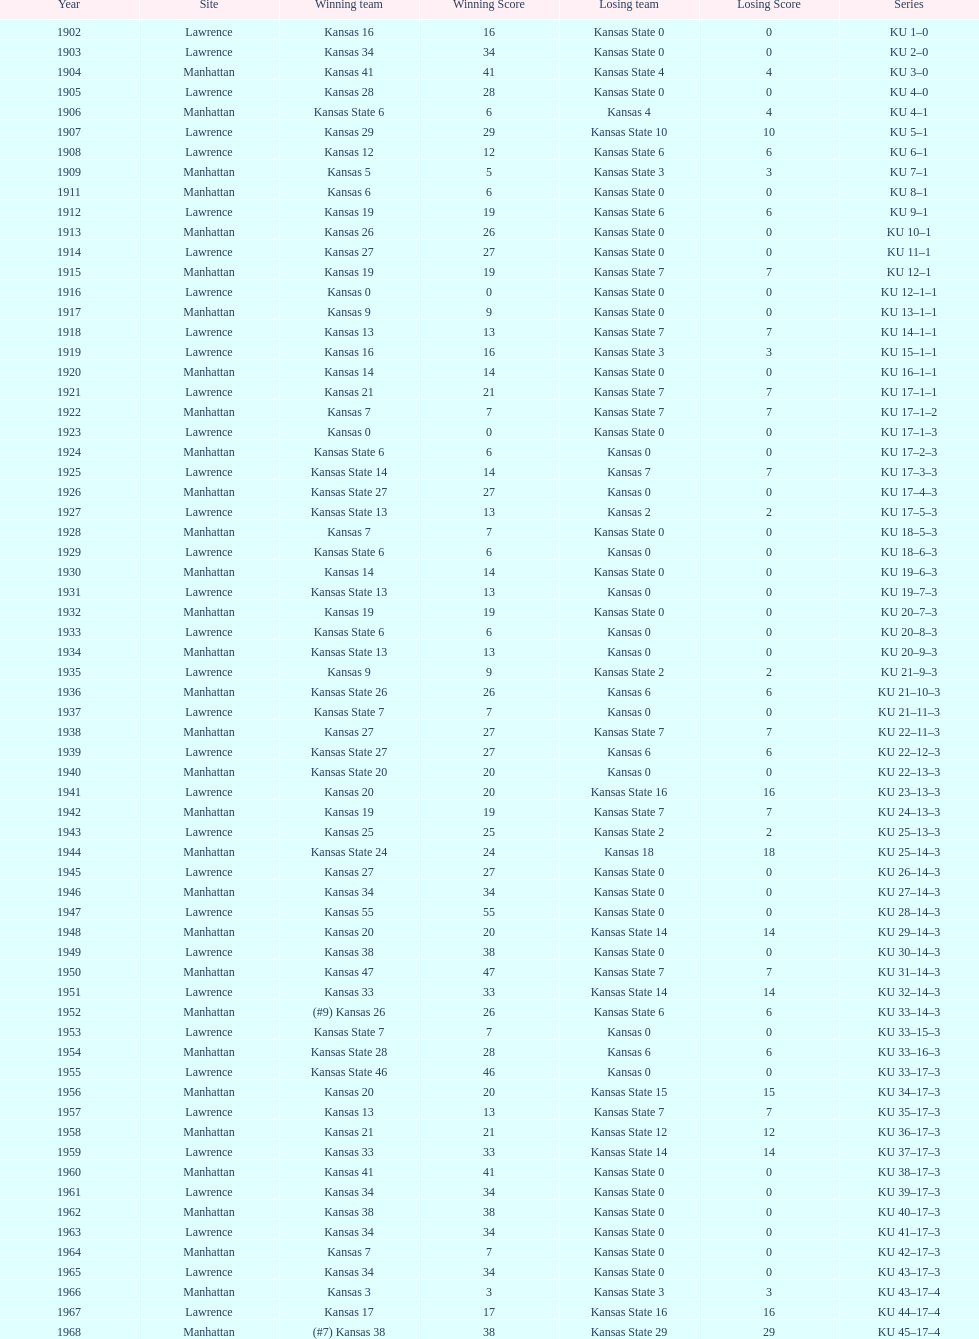Before 1950 what was the most points kansas scored? 55. 